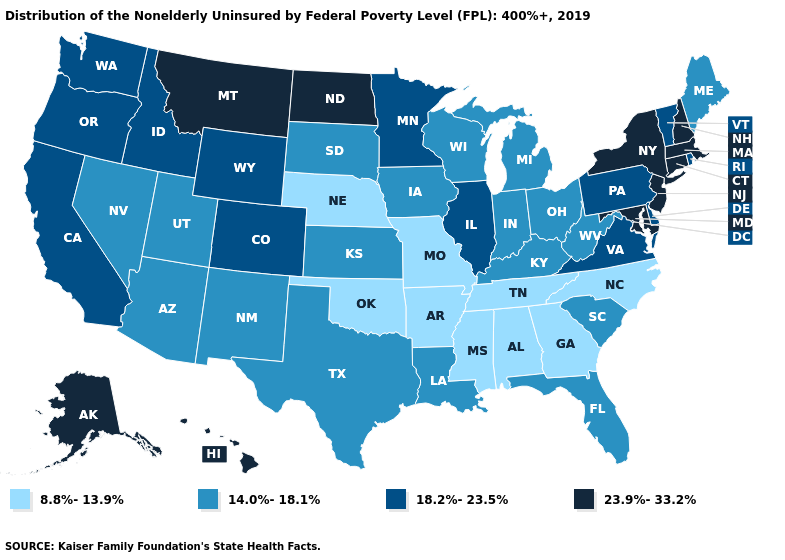Name the states that have a value in the range 14.0%-18.1%?
Keep it brief. Arizona, Florida, Indiana, Iowa, Kansas, Kentucky, Louisiana, Maine, Michigan, Nevada, New Mexico, Ohio, South Carolina, South Dakota, Texas, Utah, West Virginia, Wisconsin. Is the legend a continuous bar?
Short answer required. No. Name the states that have a value in the range 23.9%-33.2%?
Answer briefly. Alaska, Connecticut, Hawaii, Maryland, Massachusetts, Montana, New Hampshire, New Jersey, New York, North Dakota. Among the states that border West Virginia , does Ohio have the lowest value?
Concise answer only. Yes. Does South Carolina have a lower value than Illinois?
Write a very short answer. Yes. What is the highest value in the USA?
Be succinct. 23.9%-33.2%. Name the states that have a value in the range 23.9%-33.2%?
Keep it brief. Alaska, Connecticut, Hawaii, Maryland, Massachusetts, Montana, New Hampshire, New Jersey, New York, North Dakota. Name the states that have a value in the range 18.2%-23.5%?
Answer briefly. California, Colorado, Delaware, Idaho, Illinois, Minnesota, Oregon, Pennsylvania, Rhode Island, Vermont, Virginia, Washington, Wyoming. Name the states that have a value in the range 18.2%-23.5%?
Quick response, please. California, Colorado, Delaware, Idaho, Illinois, Minnesota, Oregon, Pennsylvania, Rhode Island, Vermont, Virginia, Washington, Wyoming. What is the value of Kentucky?
Write a very short answer. 14.0%-18.1%. Does Idaho have the highest value in the West?
Short answer required. No. Which states have the highest value in the USA?
Quick response, please. Alaska, Connecticut, Hawaii, Maryland, Massachusetts, Montana, New Hampshire, New Jersey, New York, North Dakota. Which states have the lowest value in the USA?
Be succinct. Alabama, Arkansas, Georgia, Mississippi, Missouri, Nebraska, North Carolina, Oklahoma, Tennessee. What is the lowest value in the USA?
Give a very brief answer. 8.8%-13.9%. What is the value of Nebraska?
Give a very brief answer. 8.8%-13.9%. 